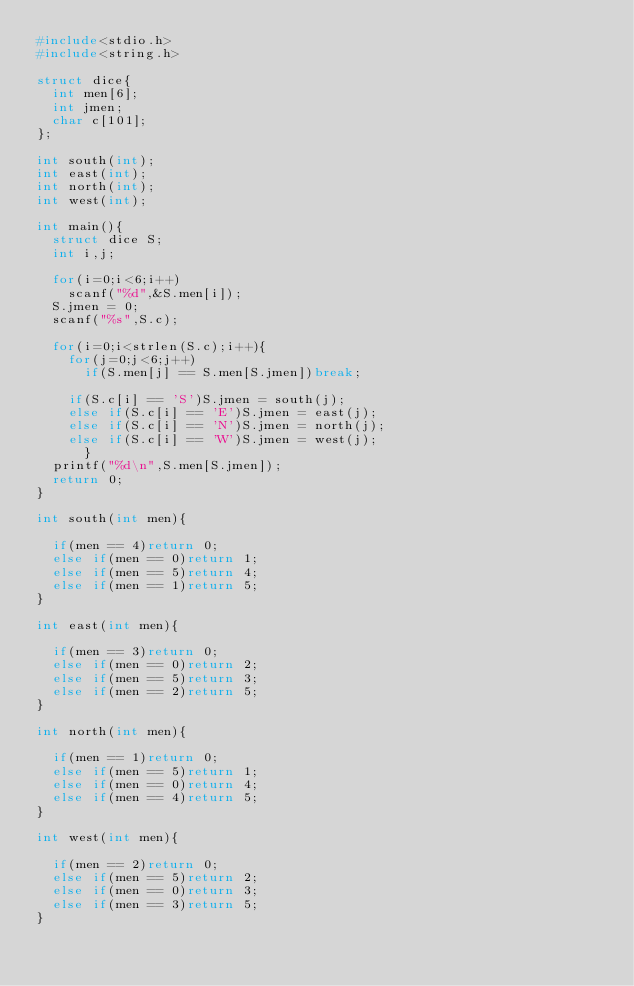<code> <loc_0><loc_0><loc_500><loc_500><_C_>#include<stdio.h>
#include<string.h>

struct dice{
  int men[6];
  int jmen;
  char c[101];
};

int south(int);
int east(int);
int north(int);
int west(int);

int main(){
  struct dice S;
  int i,j;

  for(i=0;i<6;i++)
    scanf("%d",&S.men[i]);
  S.jmen = 0;
  scanf("%s",S.c);

  for(i=0;i<strlen(S.c);i++){
    for(j=0;j<6;j++)
      if(S.men[j] == S.men[S.jmen])break;

    if(S.c[i] == 'S')S.jmen = south(j);
    else if(S.c[i] == 'E')S.jmen = east(j);
    else if(S.c[i] == 'N')S.jmen = north(j);
    else if(S.c[i] == 'W')S.jmen = west(j);
      }
  printf("%d\n",S.men[S.jmen]);
  return 0;
}

int south(int men){

  if(men == 4)return 0;
  else if(men == 0)return 1;
  else if(men == 5)return 4;
  else if(men == 1)return 5;
}

int east(int men){

  if(men == 3)return 0;
  else if(men == 0)return 2;
  else if(men == 5)return 3;
  else if(men == 2)return 5;
}

int north(int men){

  if(men == 1)return 0;
  else if(men == 5)return 1;
  else if(men == 0)return 4;
  else if(men == 4)return 5;
}

int west(int men){

  if(men == 2)return 0;
  else if(men == 5)return 2;
  else if(men == 0)return 3;
  else if(men == 3)return 5;
}</code> 